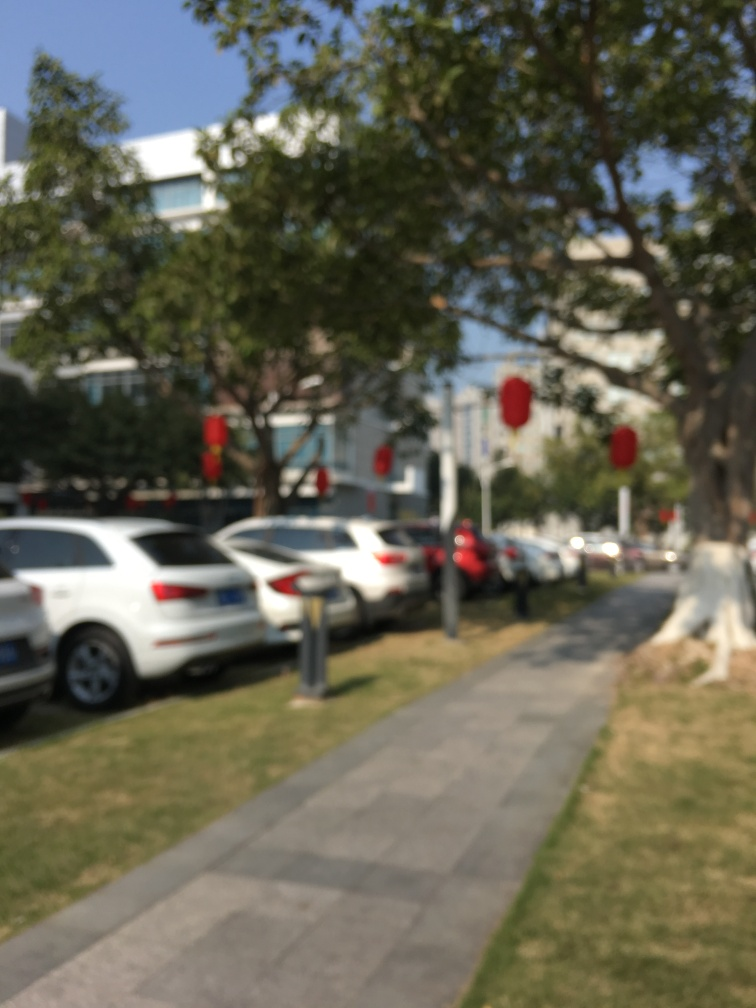Can you describe the setting of this photograph? The image appears to be taken outdoors, possibly on a street or a path lined with parked cars and trees. The scene is out of focus, but red lantern-like objects are visible hanging from the trees, suggesting a festive or celebratory occasion.  What kind of day does it seem to be? Despite the blurriness of the image, the lighting suggests it is daytime. The overall brightness and the absence of artificial lights on suggest that it is possibly midday and the weather seems to be clear. 